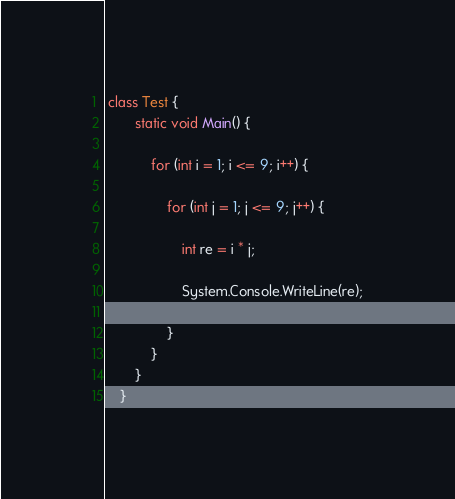Convert code to text. <code><loc_0><loc_0><loc_500><loc_500><_C#_> class Test {
		static void Main() {

			for (int i = 1; i <= 9; i++) {

				for (int j = 1; j <= 9; j++) {

					int re = i * j;

					System.Console.WriteLine(re);

				}
			}
		}
	}</code> 